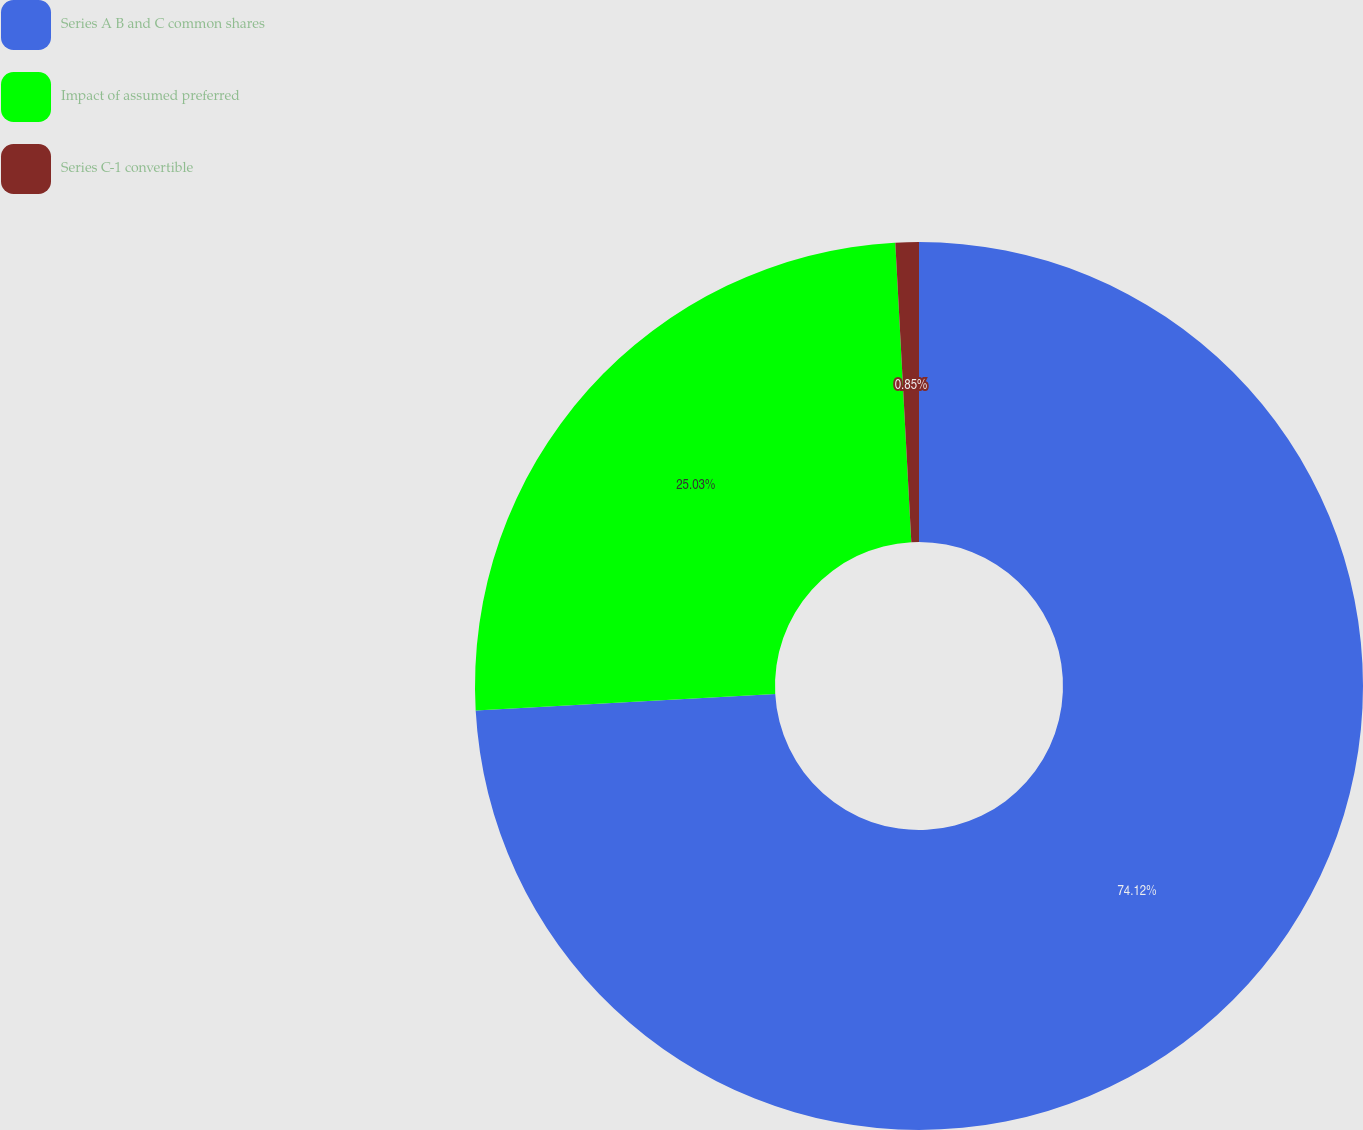Convert chart to OTSL. <chart><loc_0><loc_0><loc_500><loc_500><pie_chart><fcel>Series A B and C common shares<fcel>Impact of assumed preferred<fcel>Series C-1 convertible<nl><fcel>74.12%<fcel>25.03%<fcel>0.85%<nl></chart> 